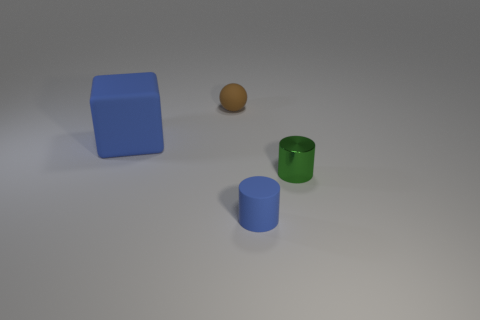Add 4 small green metallic spheres. How many objects exist? 8 Subtract all cubes. How many objects are left? 3 Subtract 0 gray blocks. How many objects are left? 4 Subtract all big cyan rubber spheres. Subtract all small brown rubber objects. How many objects are left? 3 Add 4 small green cylinders. How many small green cylinders are left? 5 Add 1 tiny matte things. How many tiny matte things exist? 3 